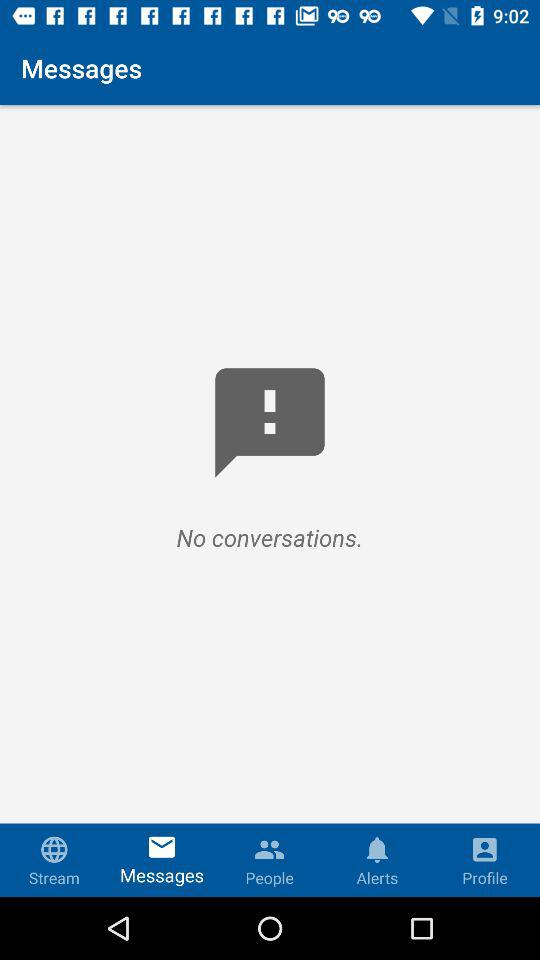Which tab is open? The tab is "Messages". 